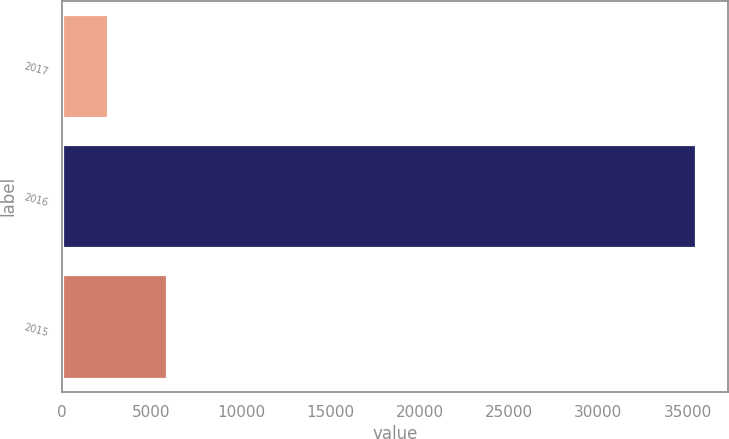Convert chart to OTSL. <chart><loc_0><loc_0><loc_500><loc_500><bar_chart><fcel>2017<fcel>2016<fcel>2015<nl><fcel>2548<fcel>35476<fcel>5840.8<nl></chart> 